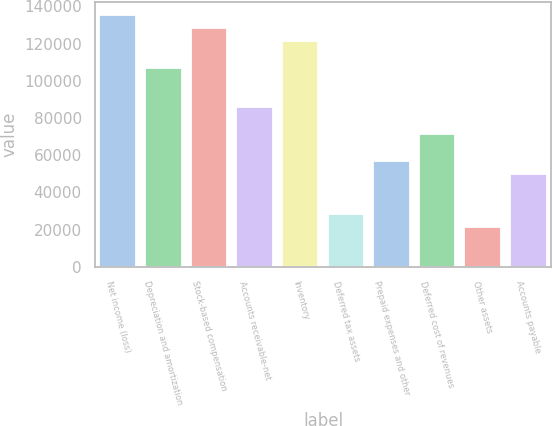Convert chart. <chart><loc_0><loc_0><loc_500><loc_500><bar_chart><fcel>Net income (loss)<fcel>Depreciation and amortization<fcel>Stock-based compensation<fcel>Accounts receivable-net<fcel>Inventory<fcel>Deferred tax assets<fcel>Prepaid expenses and other<fcel>Deferred cost of revenues<fcel>Other assets<fcel>Accounts payable<nl><fcel>135664<fcel>107107<fcel>128525<fcel>85689.4<fcel>121385<fcel>28575.8<fcel>57132.6<fcel>71411<fcel>21436.6<fcel>49993.4<nl></chart> 